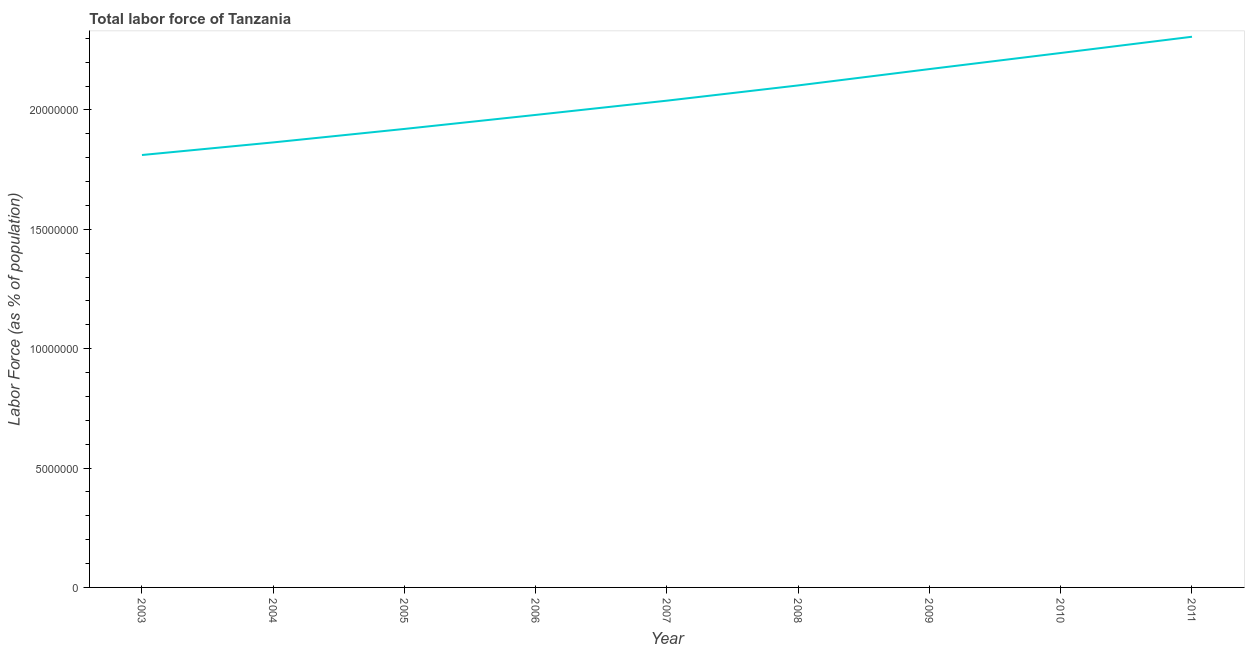What is the total labor force in 2006?
Provide a succinct answer. 1.98e+07. Across all years, what is the maximum total labor force?
Provide a succinct answer. 2.31e+07. Across all years, what is the minimum total labor force?
Your answer should be compact. 1.81e+07. In which year was the total labor force minimum?
Your answer should be compact. 2003. What is the sum of the total labor force?
Ensure brevity in your answer.  1.84e+08. What is the difference between the total labor force in 2010 and 2011?
Offer a terse response. -6.81e+05. What is the average total labor force per year?
Keep it short and to the point. 2.05e+07. What is the median total labor force?
Make the answer very short. 2.04e+07. What is the ratio of the total labor force in 2003 to that in 2010?
Give a very brief answer. 0.81. Is the total labor force in 2009 less than that in 2011?
Provide a short and direct response. Yes. What is the difference between the highest and the second highest total labor force?
Your answer should be very brief. 6.81e+05. Is the sum of the total labor force in 2005 and 2006 greater than the maximum total labor force across all years?
Keep it short and to the point. Yes. What is the difference between the highest and the lowest total labor force?
Your answer should be compact. 4.95e+06. Does the total labor force monotonically increase over the years?
Offer a very short reply. Yes. How many lines are there?
Your response must be concise. 1. How many years are there in the graph?
Give a very brief answer. 9. What is the title of the graph?
Provide a short and direct response. Total labor force of Tanzania. What is the label or title of the Y-axis?
Offer a terse response. Labor Force (as % of population). What is the Labor Force (as % of population) in 2003?
Keep it short and to the point. 1.81e+07. What is the Labor Force (as % of population) of 2004?
Offer a very short reply. 1.86e+07. What is the Labor Force (as % of population) in 2005?
Your answer should be very brief. 1.92e+07. What is the Labor Force (as % of population) of 2006?
Make the answer very short. 1.98e+07. What is the Labor Force (as % of population) in 2007?
Offer a very short reply. 2.04e+07. What is the Labor Force (as % of population) in 2008?
Give a very brief answer. 2.10e+07. What is the Labor Force (as % of population) of 2009?
Your answer should be compact. 2.17e+07. What is the Labor Force (as % of population) in 2010?
Offer a very short reply. 2.24e+07. What is the Labor Force (as % of population) in 2011?
Your response must be concise. 2.31e+07. What is the difference between the Labor Force (as % of population) in 2003 and 2004?
Your answer should be very brief. -5.28e+05. What is the difference between the Labor Force (as % of population) in 2003 and 2005?
Provide a succinct answer. -1.09e+06. What is the difference between the Labor Force (as % of population) in 2003 and 2006?
Keep it short and to the point. -1.68e+06. What is the difference between the Labor Force (as % of population) in 2003 and 2007?
Your answer should be compact. -2.28e+06. What is the difference between the Labor Force (as % of population) in 2003 and 2008?
Your answer should be compact. -2.92e+06. What is the difference between the Labor Force (as % of population) in 2003 and 2009?
Provide a short and direct response. -3.60e+06. What is the difference between the Labor Force (as % of population) in 2003 and 2010?
Offer a very short reply. -4.27e+06. What is the difference between the Labor Force (as % of population) in 2003 and 2011?
Give a very brief answer. -4.95e+06. What is the difference between the Labor Force (as % of population) in 2004 and 2005?
Provide a short and direct response. -5.64e+05. What is the difference between the Labor Force (as % of population) in 2004 and 2006?
Keep it short and to the point. -1.15e+06. What is the difference between the Labor Force (as % of population) in 2004 and 2007?
Give a very brief answer. -1.75e+06. What is the difference between the Labor Force (as % of population) in 2004 and 2008?
Make the answer very short. -2.39e+06. What is the difference between the Labor Force (as % of population) in 2004 and 2009?
Keep it short and to the point. -3.07e+06. What is the difference between the Labor Force (as % of population) in 2004 and 2010?
Offer a very short reply. -3.75e+06. What is the difference between the Labor Force (as % of population) in 2004 and 2011?
Offer a very short reply. -4.43e+06. What is the difference between the Labor Force (as % of population) in 2005 and 2006?
Give a very brief answer. -5.87e+05. What is the difference between the Labor Force (as % of population) in 2005 and 2007?
Your answer should be very brief. -1.18e+06. What is the difference between the Labor Force (as % of population) in 2005 and 2008?
Offer a terse response. -1.82e+06. What is the difference between the Labor Force (as % of population) in 2005 and 2009?
Your answer should be compact. -2.51e+06. What is the difference between the Labor Force (as % of population) in 2005 and 2010?
Offer a terse response. -3.18e+06. What is the difference between the Labor Force (as % of population) in 2005 and 2011?
Make the answer very short. -3.86e+06. What is the difference between the Labor Force (as % of population) in 2006 and 2007?
Make the answer very short. -5.97e+05. What is the difference between the Labor Force (as % of population) in 2006 and 2008?
Your answer should be compact. -1.24e+06. What is the difference between the Labor Force (as % of population) in 2006 and 2009?
Provide a succinct answer. -1.92e+06. What is the difference between the Labor Force (as % of population) in 2006 and 2010?
Offer a very short reply. -2.59e+06. What is the difference between the Labor Force (as % of population) in 2006 and 2011?
Offer a terse response. -3.27e+06. What is the difference between the Labor Force (as % of population) in 2007 and 2008?
Your response must be concise. -6.38e+05. What is the difference between the Labor Force (as % of population) in 2007 and 2009?
Keep it short and to the point. -1.32e+06. What is the difference between the Labor Force (as % of population) in 2007 and 2010?
Offer a very short reply. -2.00e+06. What is the difference between the Labor Force (as % of population) in 2007 and 2011?
Your answer should be compact. -2.68e+06. What is the difference between the Labor Force (as % of population) in 2008 and 2009?
Keep it short and to the point. -6.85e+05. What is the difference between the Labor Force (as % of population) in 2008 and 2010?
Offer a very short reply. -1.36e+06. What is the difference between the Labor Force (as % of population) in 2008 and 2011?
Your answer should be very brief. -2.04e+06. What is the difference between the Labor Force (as % of population) in 2009 and 2010?
Keep it short and to the point. -6.74e+05. What is the difference between the Labor Force (as % of population) in 2009 and 2011?
Ensure brevity in your answer.  -1.35e+06. What is the difference between the Labor Force (as % of population) in 2010 and 2011?
Make the answer very short. -6.81e+05. What is the ratio of the Labor Force (as % of population) in 2003 to that in 2004?
Provide a short and direct response. 0.97. What is the ratio of the Labor Force (as % of population) in 2003 to that in 2005?
Make the answer very short. 0.94. What is the ratio of the Labor Force (as % of population) in 2003 to that in 2006?
Make the answer very short. 0.92. What is the ratio of the Labor Force (as % of population) in 2003 to that in 2007?
Keep it short and to the point. 0.89. What is the ratio of the Labor Force (as % of population) in 2003 to that in 2008?
Your response must be concise. 0.86. What is the ratio of the Labor Force (as % of population) in 2003 to that in 2009?
Provide a succinct answer. 0.83. What is the ratio of the Labor Force (as % of population) in 2003 to that in 2010?
Your response must be concise. 0.81. What is the ratio of the Labor Force (as % of population) in 2003 to that in 2011?
Make the answer very short. 0.79. What is the ratio of the Labor Force (as % of population) in 2004 to that in 2006?
Keep it short and to the point. 0.94. What is the ratio of the Labor Force (as % of population) in 2004 to that in 2007?
Make the answer very short. 0.91. What is the ratio of the Labor Force (as % of population) in 2004 to that in 2008?
Ensure brevity in your answer.  0.89. What is the ratio of the Labor Force (as % of population) in 2004 to that in 2009?
Make the answer very short. 0.86. What is the ratio of the Labor Force (as % of population) in 2004 to that in 2010?
Make the answer very short. 0.83. What is the ratio of the Labor Force (as % of population) in 2004 to that in 2011?
Provide a short and direct response. 0.81. What is the ratio of the Labor Force (as % of population) in 2005 to that in 2006?
Your response must be concise. 0.97. What is the ratio of the Labor Force (as % of population) in 2005 to that in 2007?
Provide a short and direct response. 0.94. What is the ratio of the Labor Force (as % of population) in 2005 to that in 2008?
Offer a very short reply. 0.91. What is the ratio of the Labor Force (as % of population) in 2005 to that in 2009?
Your answer should be compact. 0.89. What is the ratio of the Labor Force (as % of population) in 2005 to that in 2010?
Ensure brevity in your answer.  0.86. What is the ratio of the Labor Force (as % of population) in 2005 to that in 2011?
Offer a very short reply. 0.83. What is the ratio of the Labor Force (as % of population) in 2006 to that in 2007?
Give a very brief answer. 0.97. What is the ratio of the Labor Force (as % of population) in 2006 to that in 2008?
Your answer should be very brief. 0.94. What is the ratio of the Labor Force (as % of population) in 2006 to that in 2009?
Provide a succinct answer. 0.91. What is the ratio of the Labor Force (as % of population) in 2006 to that in 2010?
Your answer should be compact. 0.88. What is the ratio of the Labor Force (as % of population) in 2006 to that in 2011?
Your response must be concise. 0.86. What is the ratio of the Labor Force (as % of population) in 2007 to that in 2008?
Your response must be concise. 0.97. What is the ratio of the Labor Force (as % of population) in 2007 to that in 2009?
Your response must be concise. 0.94. What is the ratio of the Labor Force (as % of population) in 2007 to that in 2010?
Make the answer very short. 0.91. What is the ratio of the Labor Force (as % of population) in 2007 to that in 2011?
Provide a succinct answer. 0.88. What is the ratio of the Labor Force (as % of population) in 2008 to that in 2009?
Keep it short and to the point. 0.97. What is the ratio of the Labor Force (as % of population) in 2008 to that in 2010?
Your answer should be very brief. 0.94. What is the ratio of the Labor Force (as % of population) in 2008 to that in 2011?
Your response must be concise. 0.91. What is the ratio of the Labor Force (as % of population) in 2009 to that in 2010?
Offer a terse response. 0.97. What is the ratio of the Labor Force (as % of population) in 2009 to that in 2011?
Provide a short and direct response. 0.94. 